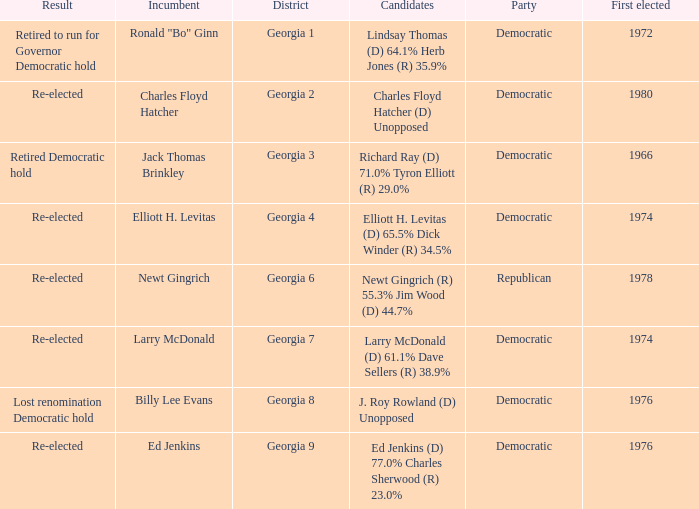Name the party for jack thomas brinkley Democratic. 